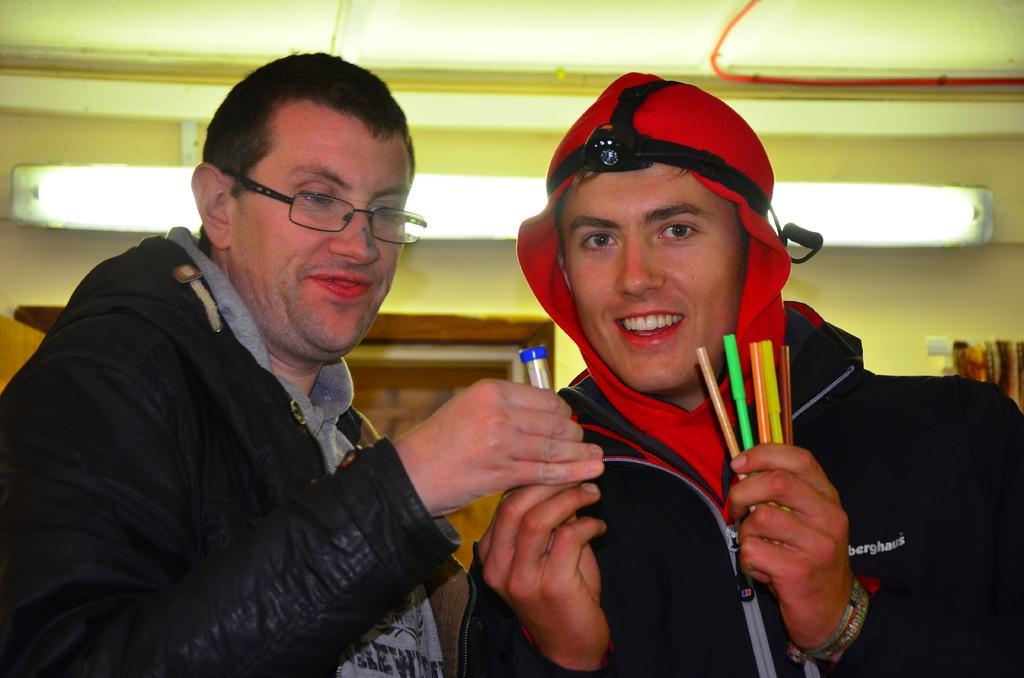How would you summarize this image in a sentence or two? In this picture I can see two persons holding some objects, and in the background there is a light and a wall. 